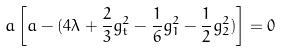Convert formula to latex. <formula><loc_0><loc_0><loc_500><loc_500>a \left [ a - ( 4 \lambda + { \frac { 2 } { 3 } } g _ { t } ^ { 2 } - { \frac { 1 } { 6 } } g _ { 1 } ^ { 2 } - { \frac { 1 } { 2 } } g _ { 2 } ^ { 2 } ) \right ] = 0</formula> 